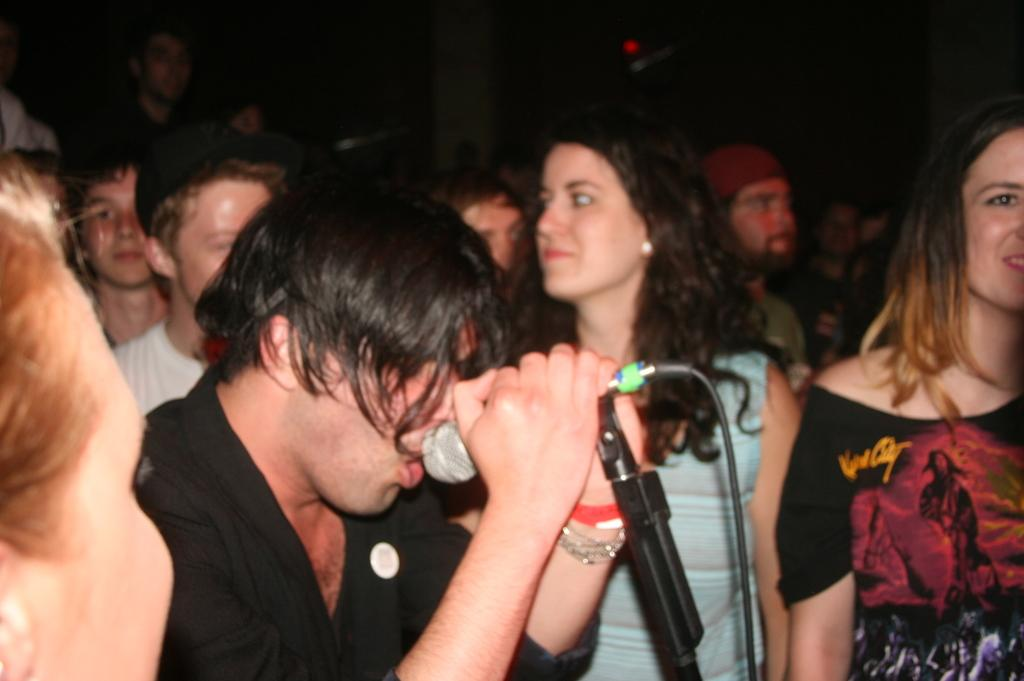How many individuals can be seen in the image? There are many people in the image. Can you describe the gender distribution of the people in the image? Both girls and boys are present in the image. What object is used for amplifying sound in the image? There is a microphone in the image. What type of wire is visible in the image? There is a cable wire in the image. What type of lamp can be seen in the image? There is no lamp present in the image. What does the image smell like? The image does not have a smell, as it is a visual representation. 